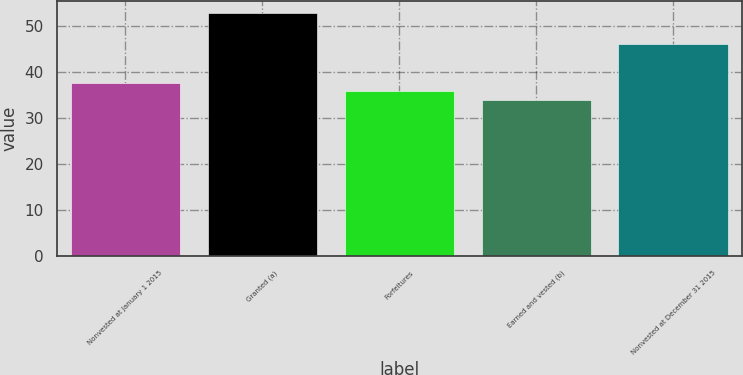<chart> <loc_0><loc_0><loc_500><loc_500><bar_chart><fcel>Nonvested at January 1 2015<fcel>Granted (a)<fcel>Forfeitures<fcel>Earned and vested (b)<fcel>Nonvested at December 31 2015<nl><fcel>37.73<fcel>52.88<fcel>35.83<fcel>33.93<fcel>46.08<nl></chart> 